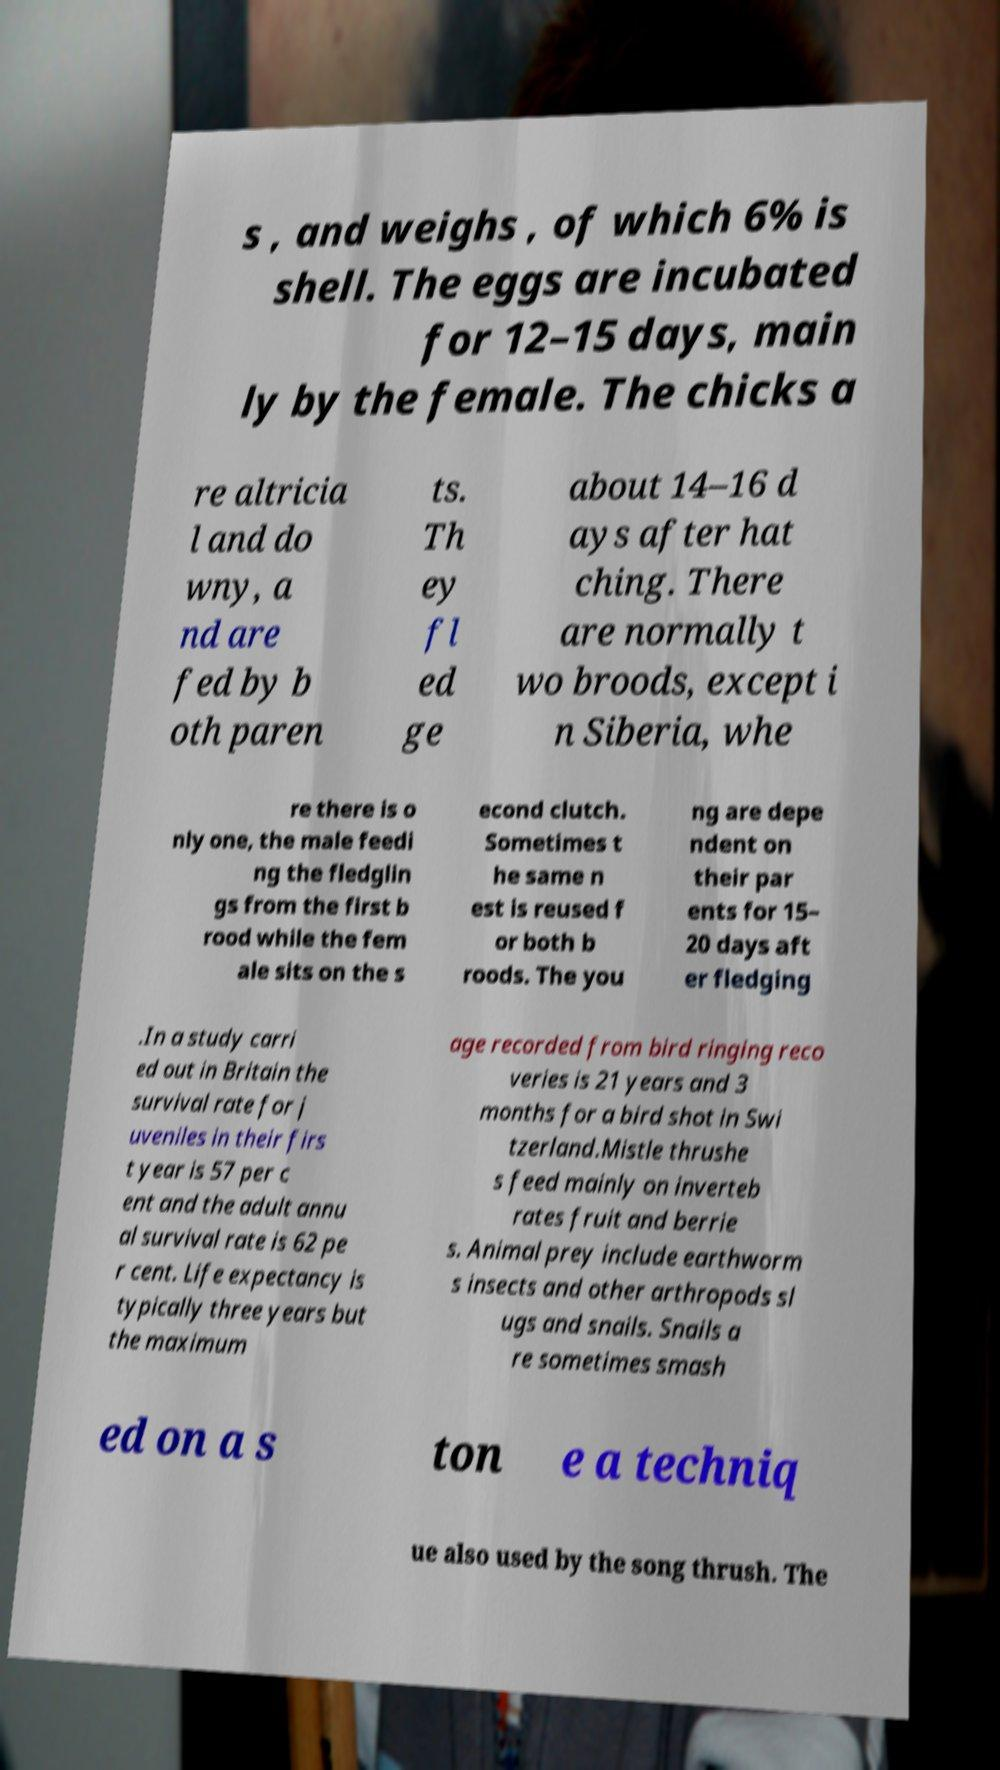Please identify and transcribe the text found in this image. s , and weighs , of which 6% is shell. The eggs are incubated for 12–15 days, main ly by the female. The chicks a re altricia l and do wny, a nd are fed by b oth paren ts. Th ey fl ed ge about 14–16 d ays after hat ching. There are normally t wo broods, except i n Siberia, whe re there is o nly one, the male feedi ng the fledglin gs from the first b rood while the fem ale sits on the s econd clutch. Sometimes t he same n est is reused f or both b roods. The you ng are depe ndent on their par ents for 15– 20 days aft er fledging .In a study carri ed out in Britain the survival rate for j uveniles in their firs t year is 57 per c ent and the adult annu al survival rate is 62 pe r cent. Life expectancy is typically three years but the maximum age recorded from bird ringing reco veries is 21 years and 3 months for a bird shot in Swi tzerland.Mistle thrushe s feed mainly on inverteb rates fruit and berrie s. Animal prey include earthworm s insects and other arthropods sl ugs and snails. Snails a re sometimes smash ed on a s ton e a techniq ue also used by the song thrush. The 